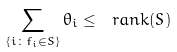Convert formula to latex. <formula><loc_0><loc_0><loc_500><loc_500>\sum _ { \{ i \colon f _ { i } \in S \} } \theta _ { i } \leq \ r a n k ( S )</formula> 